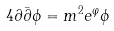<formula> <loc_0><loc_0><loc_500><loc_500>4 \partial \bar { \partial } \phi = m ^ { 2 } e ^ { \varphi } \phi</formula> 